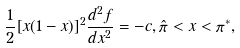<formula> <loc_0><loc_0><loc_500><loc_500>\frac { 1 } { 2 } [ x ( 1 - x ) ] ^ { 2 } \frac { d ^ { 2 } f } { d x ^ { 2 } } = - c , \hat { \pi } < x < \pi ^ { * } ,</formula> 